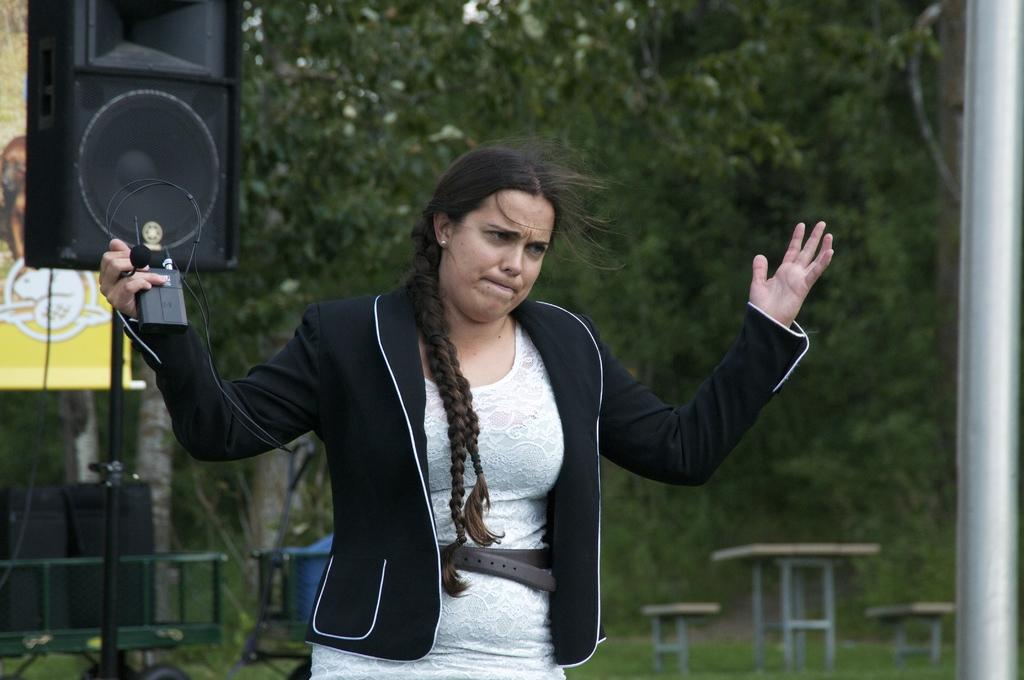What is the main subject of the image? There is a woman standing in the center of the image. What can be seen in the background of the image? In the background, there is a speaker, an advertisement, tables, and trees. Can you describe the speaker in the image? The speaker is located in the background of the image. What type of vegetation is visible in the background? Trees are visible in the background of the image. How many dimes are scattered on the ground in the image? There are no dimes present in the image. What type of sail can be seen on the woman's clothing in the image? The woman's clothing does not feature a sail; she is not wearing any sail-like garments. 